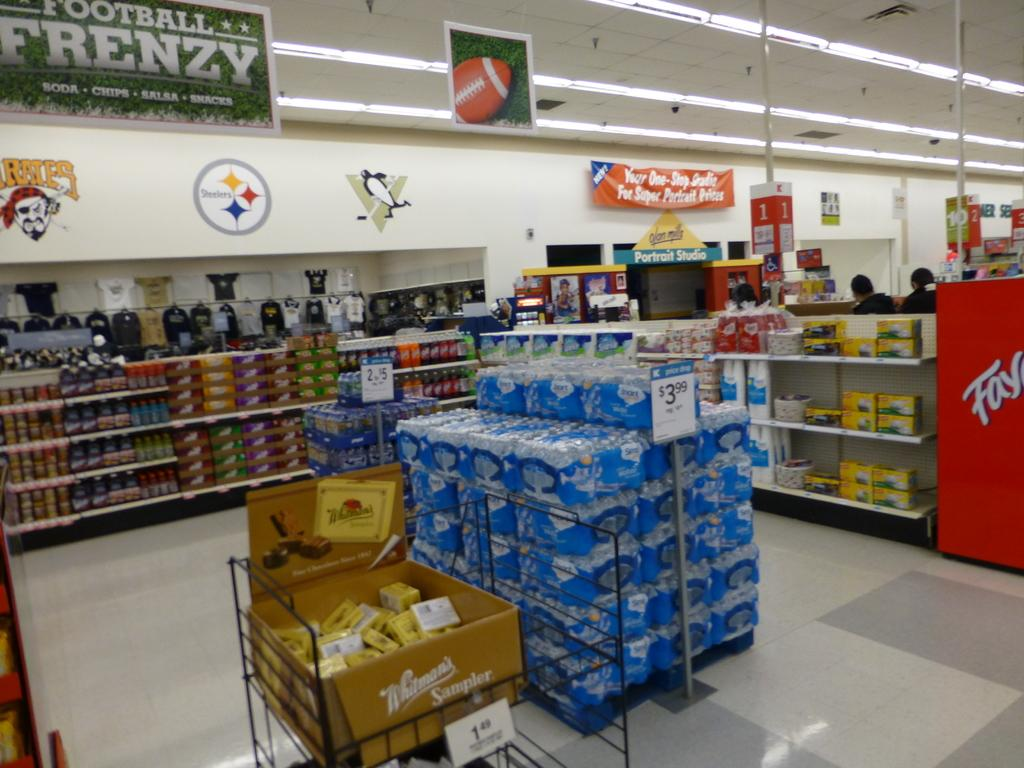<image>
Summarize the visual content of the image. The off-license section of a supermarket advertises football frenzy. 